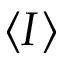Convert formula to latex. <formula><loc_0><loc_0><loc_500><loc_500>I</formula> 